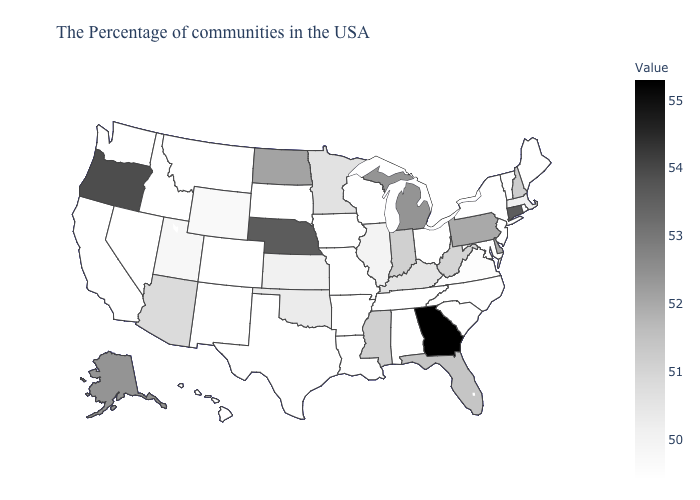Among the states that border Oregon , which have the lowest value?
Answer briefly. Idaho, Nevada, California, Washington. Does Georgia have the highest value in the South?
Write a very short answer. Yes. Among the states that border Nebraska , does Wyoming have the lowest value?
Concise answer only. No. Which states have the lowest value in the USA?
Concise answer only. Maine, Rhode Island, Vermont, New York, New Jersey, Maryland, North Carolina, South Carolina, Ohio, Alabama, Tennessee, Wisconsin, Louisiana, Missouri, Arkansas, Iowa, Texas, South Dakota, Colorado, New Mexico, Montana, Idaho, Nevada, California, Washington, Hawaii. Which states have the lowest value in the South?
Short answer required. Maryland, North Carolina, South Carolina, Alabama, Tennessee, Louisiana, Arkansas, Texas. 